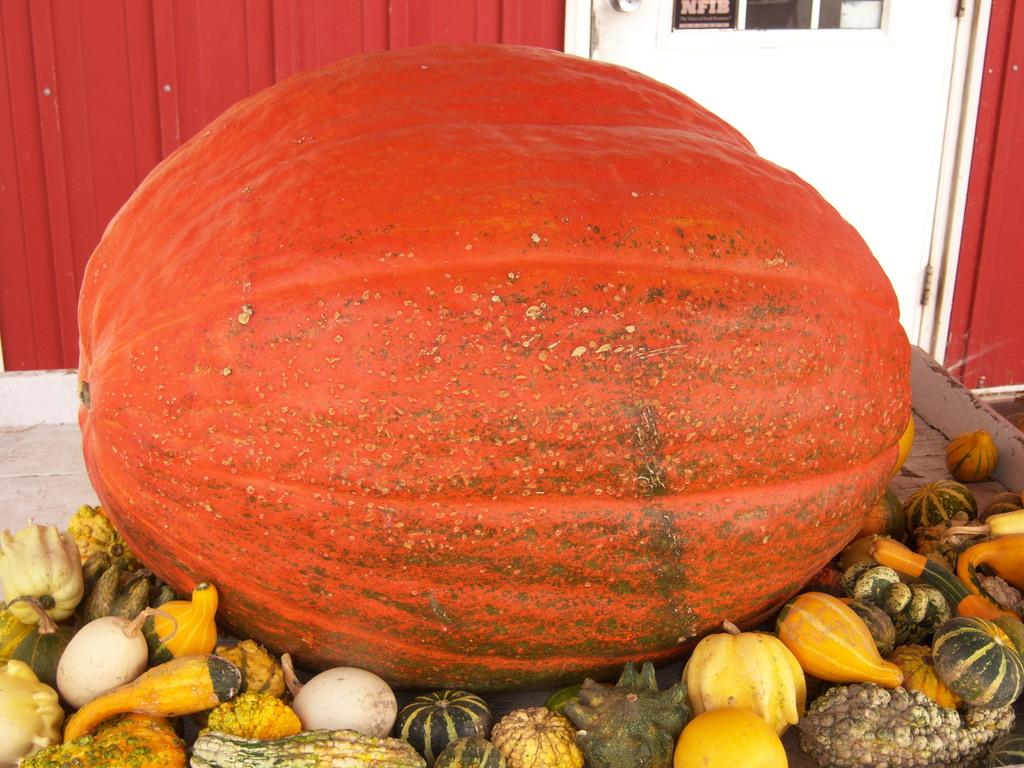What types of food items are visible in the image? There are fruits and vegetables in the image. Where are the fruits and vegetables located? The fruits and vegetables are on a surface. What can be seen in the background of the image? There is a red color wall and a white color door in the background of the image. What type of disease can be seen affecting the fruits in the image? There is no disease affecting the fruits in the image; they appear to be fresh and healthy. 